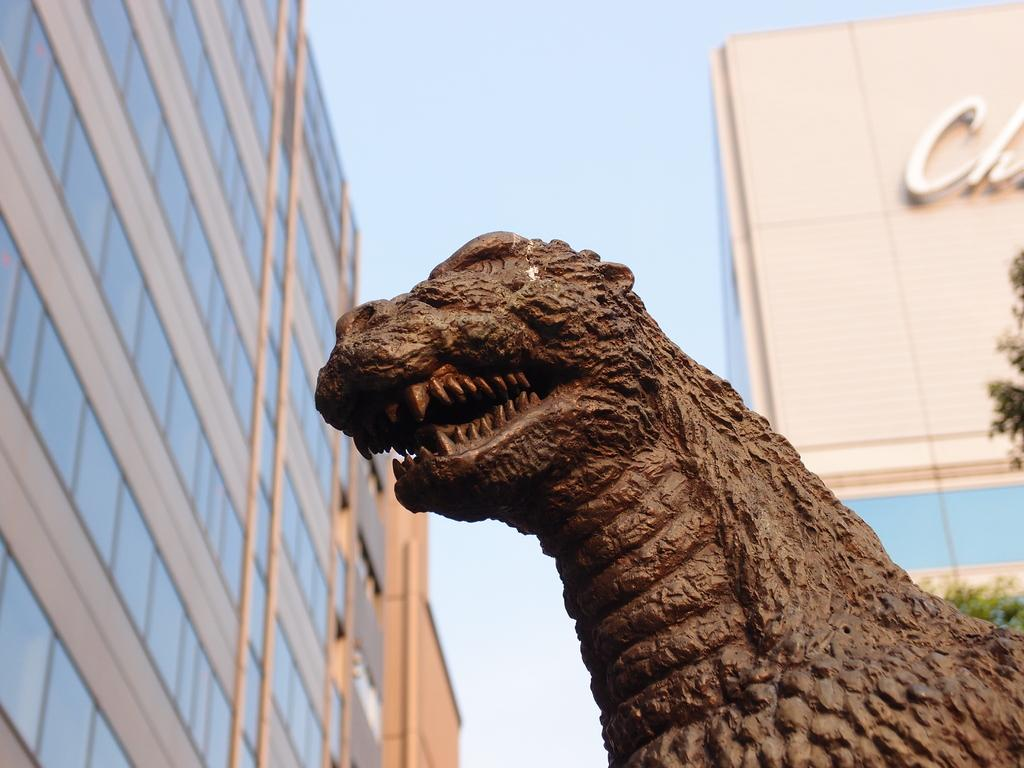What type of structures can be seen in the image? There are buildings in the image. What natural elements are present in the image? There are tree branches in the image. What type of statue is in the image? There is a statue of an animal in the image. How would you describe the sky in the image? The sky is cloudy in the image. What can be found on the wall of one of the buildings? There is text on the wall of a building in the image. How does the zebra's voice sound in the image? There is no zebra present in the image, so it is not possible to determine the sound of its voice. 